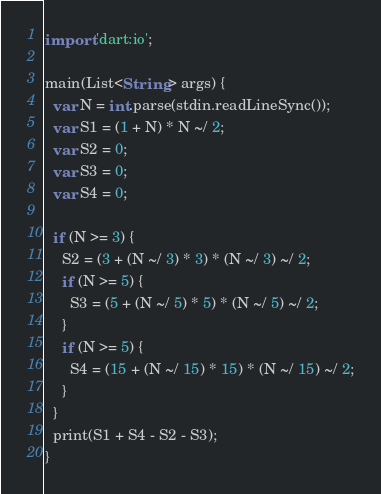Convert code to text. <code><loc_0><loc_0><loc_500><loc_500><_Dart_>import 'dart:io';

main(List<String> args) {
  var N = int.parse(stdin.readLineSync());
  var S1 = (1 + N) * N ~/ 2;
  var S2 = 0;
  var S3 = 0;
  var S4 = 0;

  if (N >= 3) {
    S2 = (3 + (N ~/ 3) * 3) * (N ~/ 3) ~/ 2;
    if (N >= 5) {
      S3 = (5 + (N ~/ 5) * 5) * (N ~/ 5) ~/ 2;
    }
    if (N >= 5) {
      S4 = (15 + (N ~/ 15) * 15) * (N ~/ 15) ~/ 2;
    }
  }
  print(S1 + S4 - S2 - S3);
}
</code> 